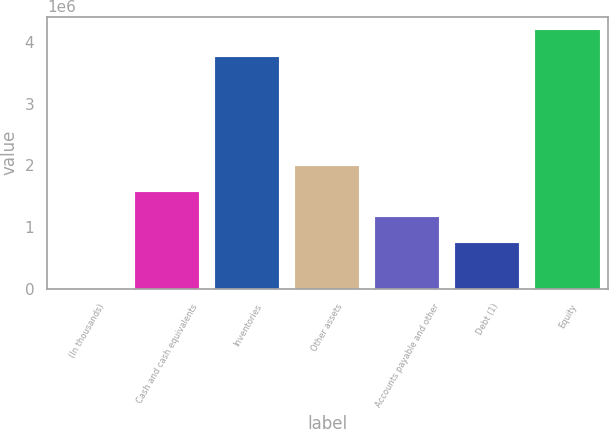Convert chart. <chart><loc_0><loc_0><loc_500><loc_500><bar_chart><fcel>(In thousands)<fcel>Cash and cash equivalents<fcel>Inventories<fcel>Other assets<fcel>Accounts payable and other<fcel>Debt (1)<fcel>Equity<nl><fcel>2017<fcel>1.57629e+06<fcel>3.75152e+06<fcel>1.99577e+06<fcel>1.15681e+06<fcel>737331<fcel>4.19681e+06<nl></chart> 